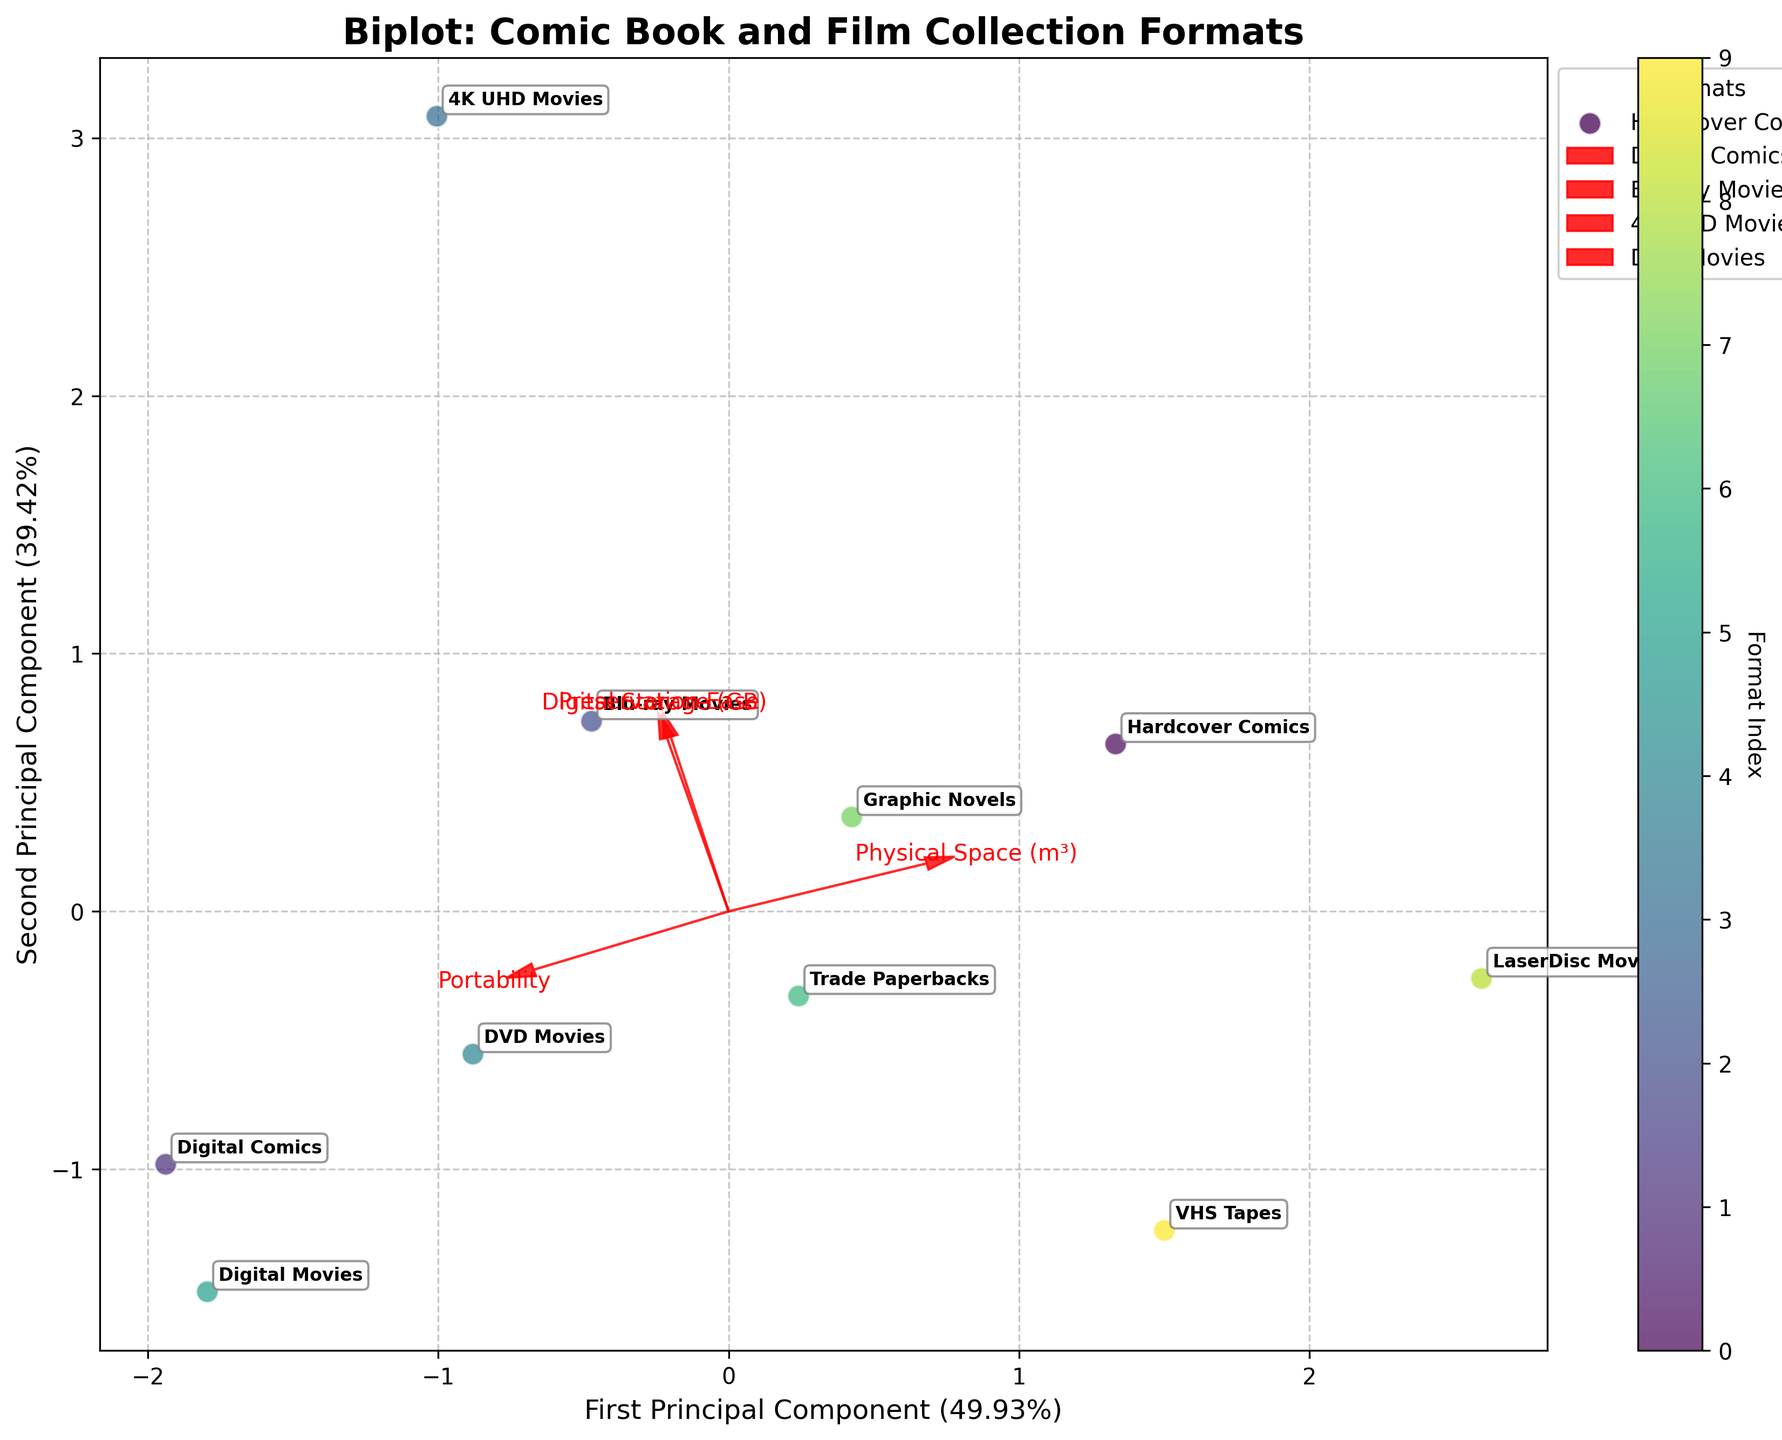How many data points are plotted in the figure? The figure has labeled points for each collection format in the dataset. Count these labels to determine the number of data points.
Answer: 10 What is the title of the plot? The title is usually placed at the top of the plot and provides an overview of what the figure represents.
Answer: Biplot: Comic Book and Film Collection Formats Which format requires the most physical space? Identify the format label placed farthest in the direction of the Physical Space (m³) vector.
Answer: LaserDisc Movies Which format is the most portable? Identify the format label placed farthest in the direction of the Portability vector.
Answer: Digital Comics Which two formats are closest to each other in the first principal component? Look at the x-coordinates in the biplot and identify the two labels that are nearest along the horizontal axis.
Answer: Trade Paperbacks and Graphic Novels Which format has similar characteristics in terms of portability and preservation ease as Blu-ray Movies? Compare the position of Blu-ray Movies to other formats in the biplot, focusing on proximity to the Portability and Preservation Ease vectors.
Answer: 4K UHD Movies What is the direction of the Digital Storage (GB) vector? Identify the orientation of the arrow labeled Digital Storage (GB), whether it's going left, right, up, or down.
Answer: Mostly right Rank the formats by their preservation ease from highest to lowest. Analyze the placement of the format labels relative to the Preservation Ease vector, sorting them from furthest in the positive direction to furthest in the negative direction.
Answer: 4K UHD Movies, Blu-ray Movies, Hardcover Comics, Graphic Novels, DVD Movies, Trade Paperbacks, Digital Comics, Digital Movies, LaserDisc Movies, VHS Tapes 